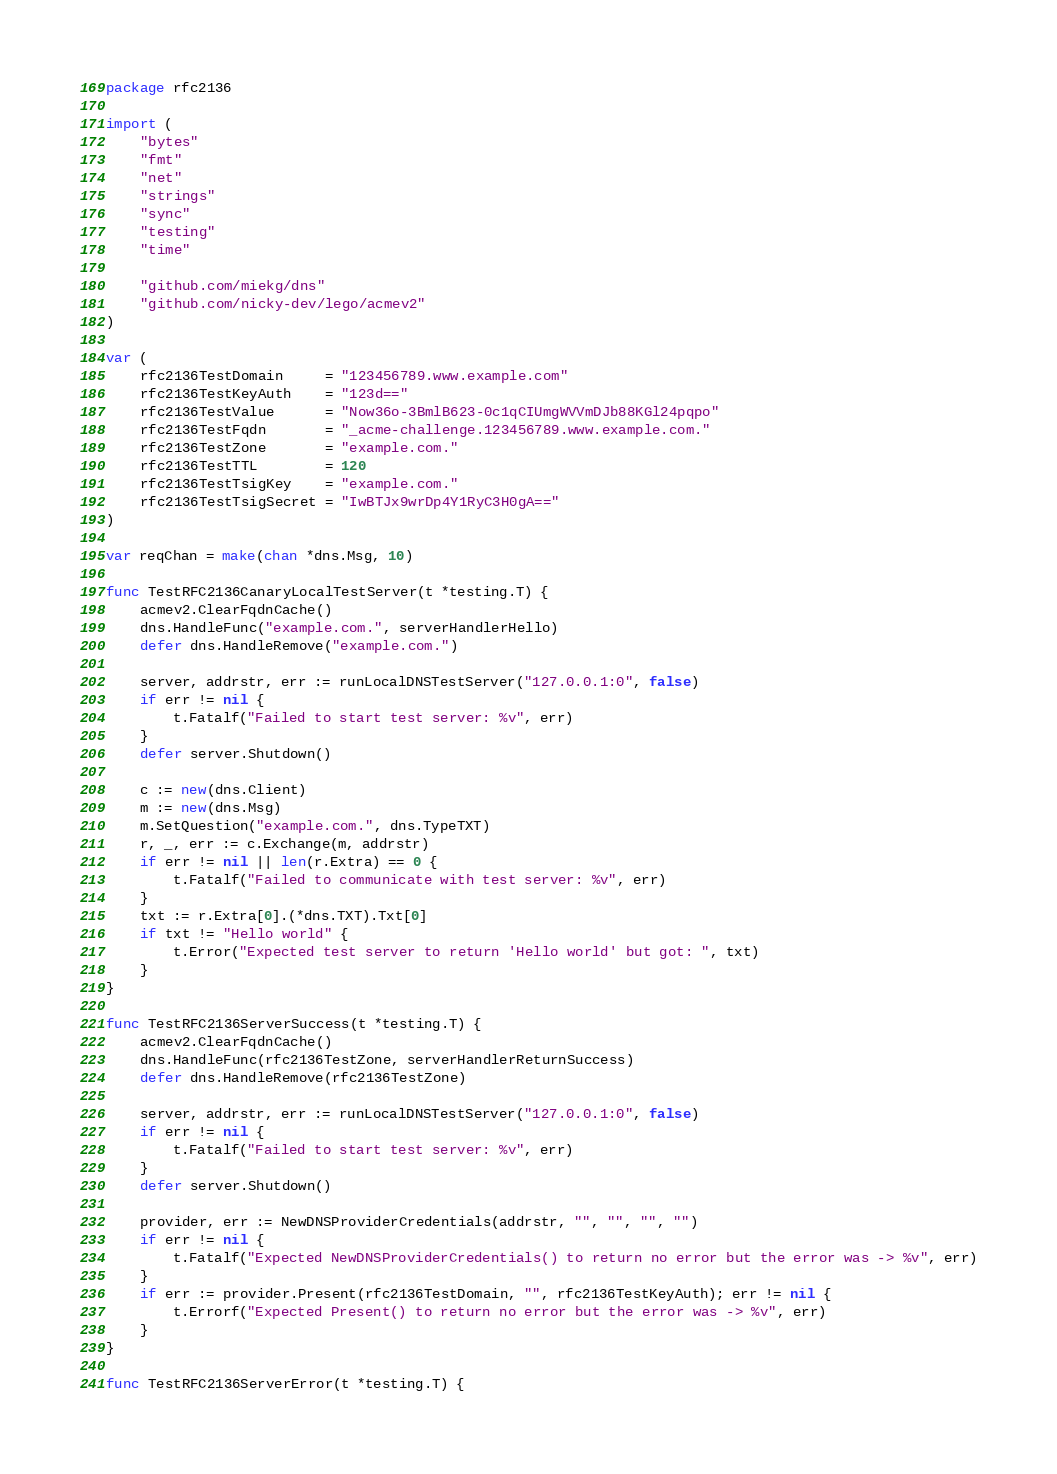<code> <loc_0><loc_0><loc_500><loc_500><_Go_>package rfc2136

import (
	"bytes"
	"fmt"
	"net"
	"strings"
	"sync"
	"testing"
	"time"

	"github.com/miekg/dns"
	"github.com/nicky-dev/lego/acmev2"
)

var (
	rfc2136TestDomain     = "123456789.www.example.com"
	rfc2136TestKeyAuth    = "123d=="
	rfc2136TestValue      = "Now36o-3BmlB623-0c1qCIUmgWVVmDJb88KGl24pqpo"
	rfc2136TestFqdn       = "_acme-challenge.123456789.www.example.com."
	rfc2136TestZone       = "example.com."
	rfc2136TestTTL        = 120
	rfc2136TestTsigKey    = "example.com."
	rfc2136TestTsigSecret = "IwBTJx9wrDp4Y1RyC3H0gA=="
)

var reqChan = make(chan *dns.Msg, 10)

func TestRFC2136CanaryLocalTestServer(t *testing.T) {
	acmev2.ClearFqdnCache()
	dns.HandleFunc("example.com.", serverHandlerHello)
	defer dns.HandleRemove("example.com.")

	server, addrstr, err := runLocalDNSTestServer("127.0.0.1:0", false)
	if err != nil {
		t.Fatalf("Failed to start test server: %v", err)
	}
	defer server.Shutdown()

	c := new(dns.Client)
	m := new(dns.Msg)
	m.SetQuestion("example.com.", dns.TypeTXT)
	r, _, err := c.Exchange(m, addrstr)
	if err != nil || len(r.Extra) == 0 {
		t.Fatalf("Failed to communicate with test server: %v", err)
	}
	txt := r.Extra[0].(*dns.TXT).Txt[0]
	if txt != "Hello world" {
		t.Error("Expected test server to return 'Hello world' but got: ", txt)
	}
}

func TestRFC2136ServerSuccess(t *testing.T) {
	acmev2.ClearFqdnCache()
	dns.HandleFunc(rfc2136TestZone, serverHandlerReturnSuccess)
	defer dns.HandleRemove(rfc2136TestZone)

	server, addrstr, err := runLocalDNSTestServer("127.0.0.1:0", false)
	if err != nil {
		t.Fatalf("Failed to start test server: %v", err)
	}
	defer server.Shutdown()

	provider, err := NewDNSProviderCredentials(addrstr, "", "", "", "")
	if err != nil {
		t.Fatalf("Expected NewDNSProviderCredentials() to return no error but the error was -> %v", err)
	}
	if err := provider.Present(rfc2136TestDomain, "", rfc2136TestKeyAuth); err != nil {
		t.Errorf("Expected Present() to return no error but the error was -> %v", err)
	}
}

func TestRFC2136ServerError(t *testing.T) {</code> 